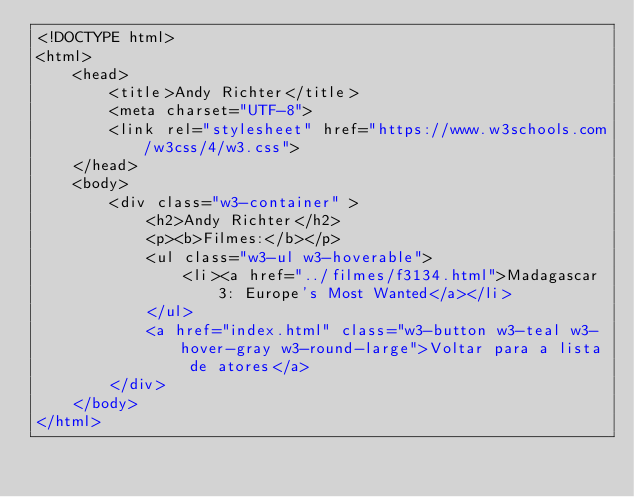<code> <loc_0><loc_0><loc_500><loc_500><_HTML_><!DOCTYPE html>
<html>
    <head>
        <title>Andy Richter</title>
        <meta charset="UTF-8">
        <link rel="stylesheet" href="https://www.w3schools.com/w3css/4/w3.css">
    </head>
    <body>
        <div class="w3-container" >
            <h2>Andy Richter</h2>
            <p><b>Filmes:</b></p>
            <ul class="w3-ul w3-hoverable">
				<li><a href="../filmes/f3134.html">Madagascar 3: Europe's Most Wanted</a></li>
			</ul>
            <a href="index.html" class="w3-button w3-teal w3-hover-gray w3-round-large">Voltar para a lista de atores</a>
        </div>
    </body>
</html></code> 